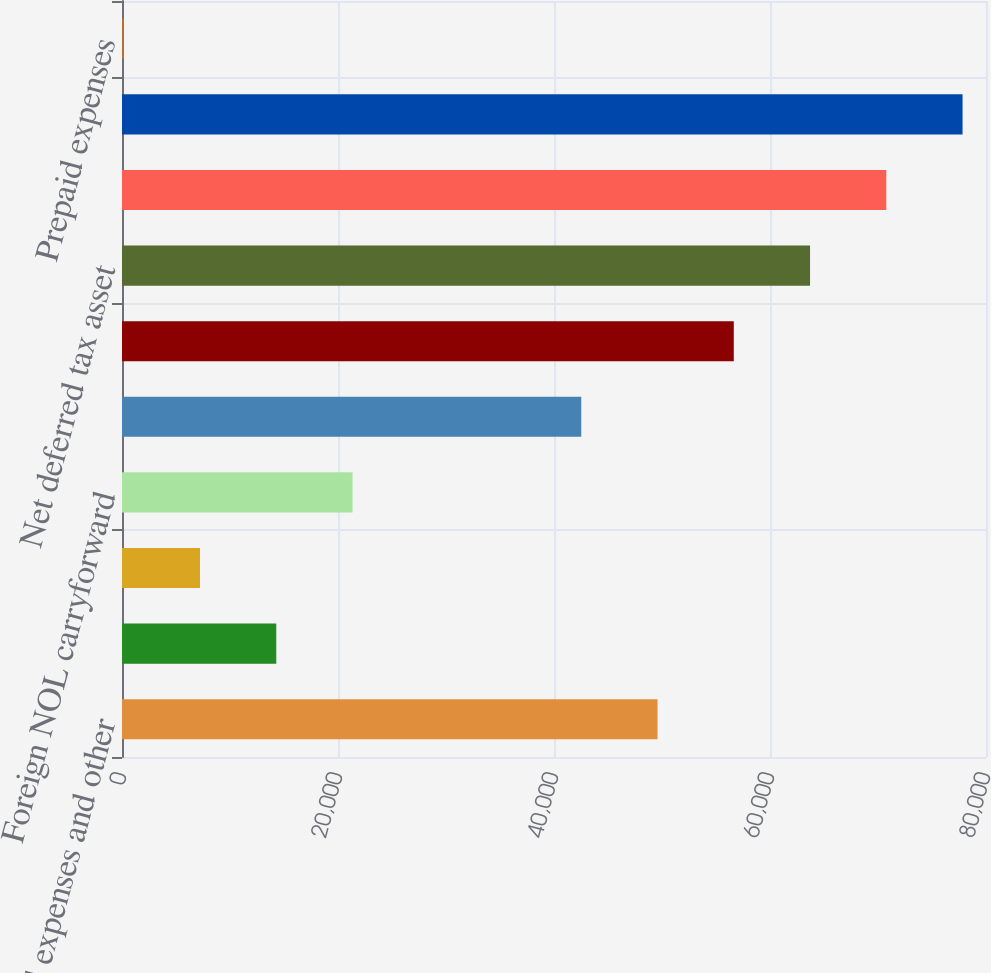Convert chart to OTSL. <chart><loc_0><loc_0><loc_500><loc_500><bar_chart><fcel>Accrued expenses and other<fcel>Bad debt expense<fcel>Accrued restructuring<fcel>Foreign NOL carryforward<fcel>Tax credits<fcel>Less valuation allowance<fcel>Net deferred tax asset<fcel>Foreign currency translation<fcel>Acquired intangibles<fcel>Prepaid expenses<nl><fcel>49586.5<fcel>14284<fcel>7223.5<fcel>21344.5<fcel>42526<fcel>56647<fcel>63707.5<fcel>70768<fcel>77828.5<fcel>163<nl></chart> 